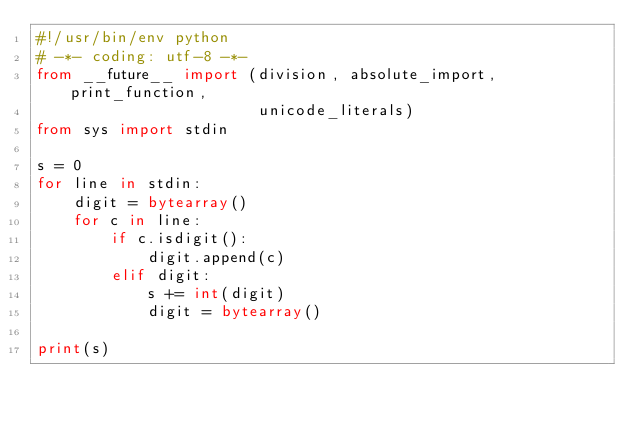<code> <loc_0><loc_0><loc_500><loc_500><_Python_>#!/usr/bin/env python
# -*- coding: utf-8 -*-
from __future__ import (division, absolute_import, print_function,
                        unicode_literals)
from sys import stdin

s = 0
for line in stdin:
    digit = bytearray()
    for c in line:
        if c.isdigit():
            digit.append(c)
        elif digit:
            s += int(digit)
            digit = bytearray()

print(s)</code> 